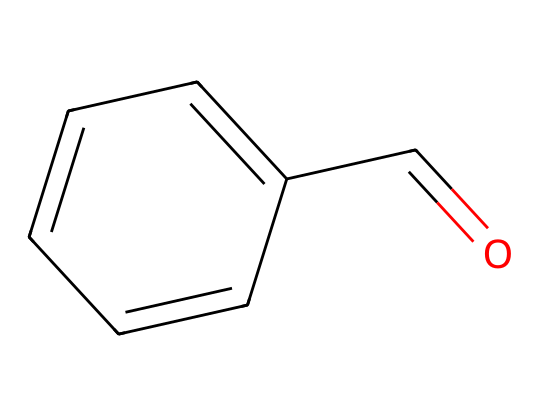What is the molecular formula of this compound? By examining the structure represented by the SMILES, we can count the carbon (C), hydrogen (H), and oxygen (O) atoms. In the structure, there are 8 carbon atoms, 8 hydrogen atoms, and 1 oxygen atom, giving the molecular formula C8H8O.
Answer: C8H8O How many aromatic rings are present in this molecule? The structure contains a benzene ring, which is recognized by the alternating double bonds in the C1=CC=C(C=C1) portion of the SMILES. Therefore, there is one aromatic ring present.
Answer: 1 What functional group is found in benzaldehyde? In the chemical structure, we can identify the carbonyl group (C=O) attached to the benzene ring. This specific attachment indicates the presence of an aldehyde functional group.
Answer: aldehyde What is the total number of double bonds in this compound? By analyzing the structure, we can observe the alternating double bonds in the benzene ring as well as the double bond in the carbonyl group (C=O). In total, there are 4 double bonds in this molecule.
Answer: 4 What type of scent is associated with benzaldehyde? Benzaldehyde is commonly known for its almond-like scent, which is often associated with various culinary and aromatic applications.
Answer: almond In what type of environments can you commonly find benzaldehyde? Benzaldehyde is naturally found in many urban parks and gardens, where its sweet, almond-like scent can be detected, often from flowering trees or plants that produce this compound.
Answer: urban parks and gardens 